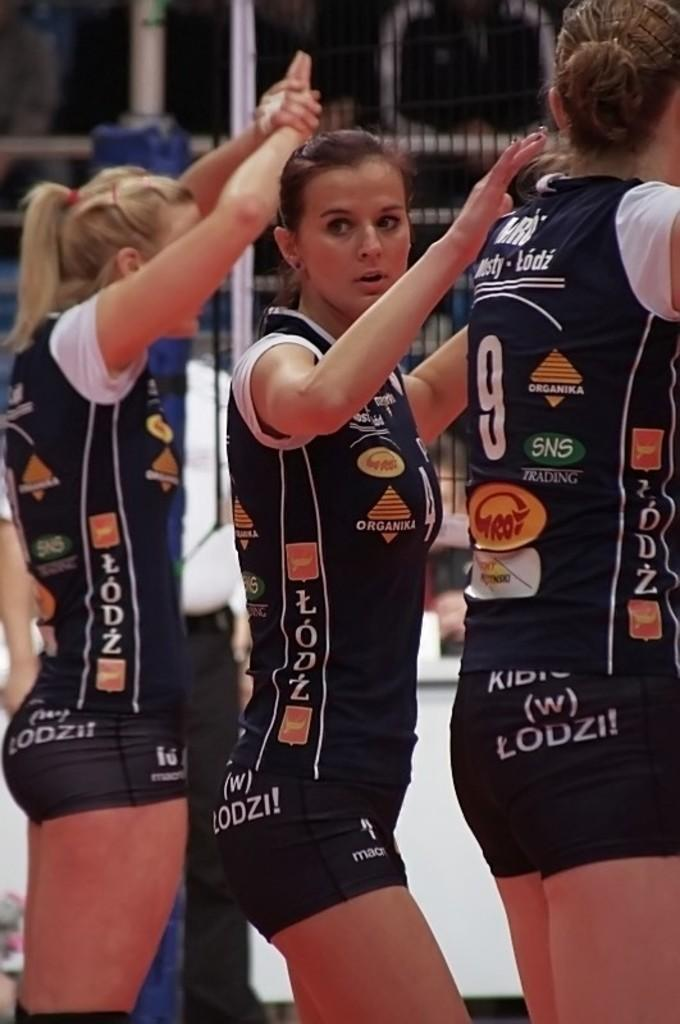<image>
Write a terse but informative summary of the picture. Athlete wearing a shirt which says "organika" on it. 